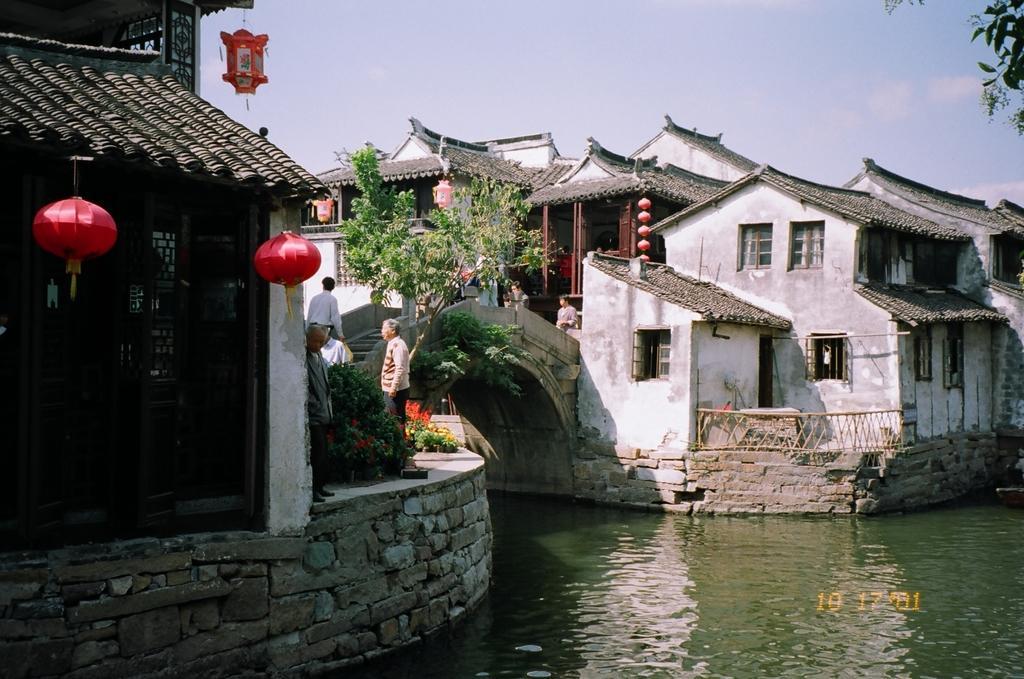Could you give a brief overview of what you see in this image? In this picture we can see bridgewater, houses, lamps, plants, people, trees and sky. 